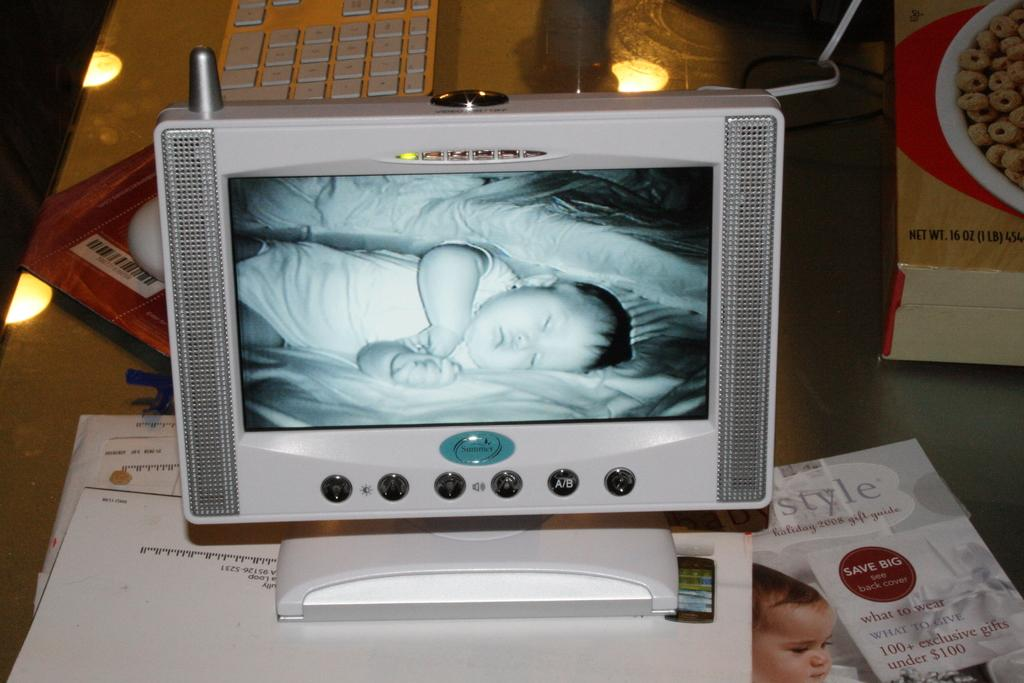<image>
Give a short and clear explanation of the subsequent image. a baby on a tv with the word Summer below it 